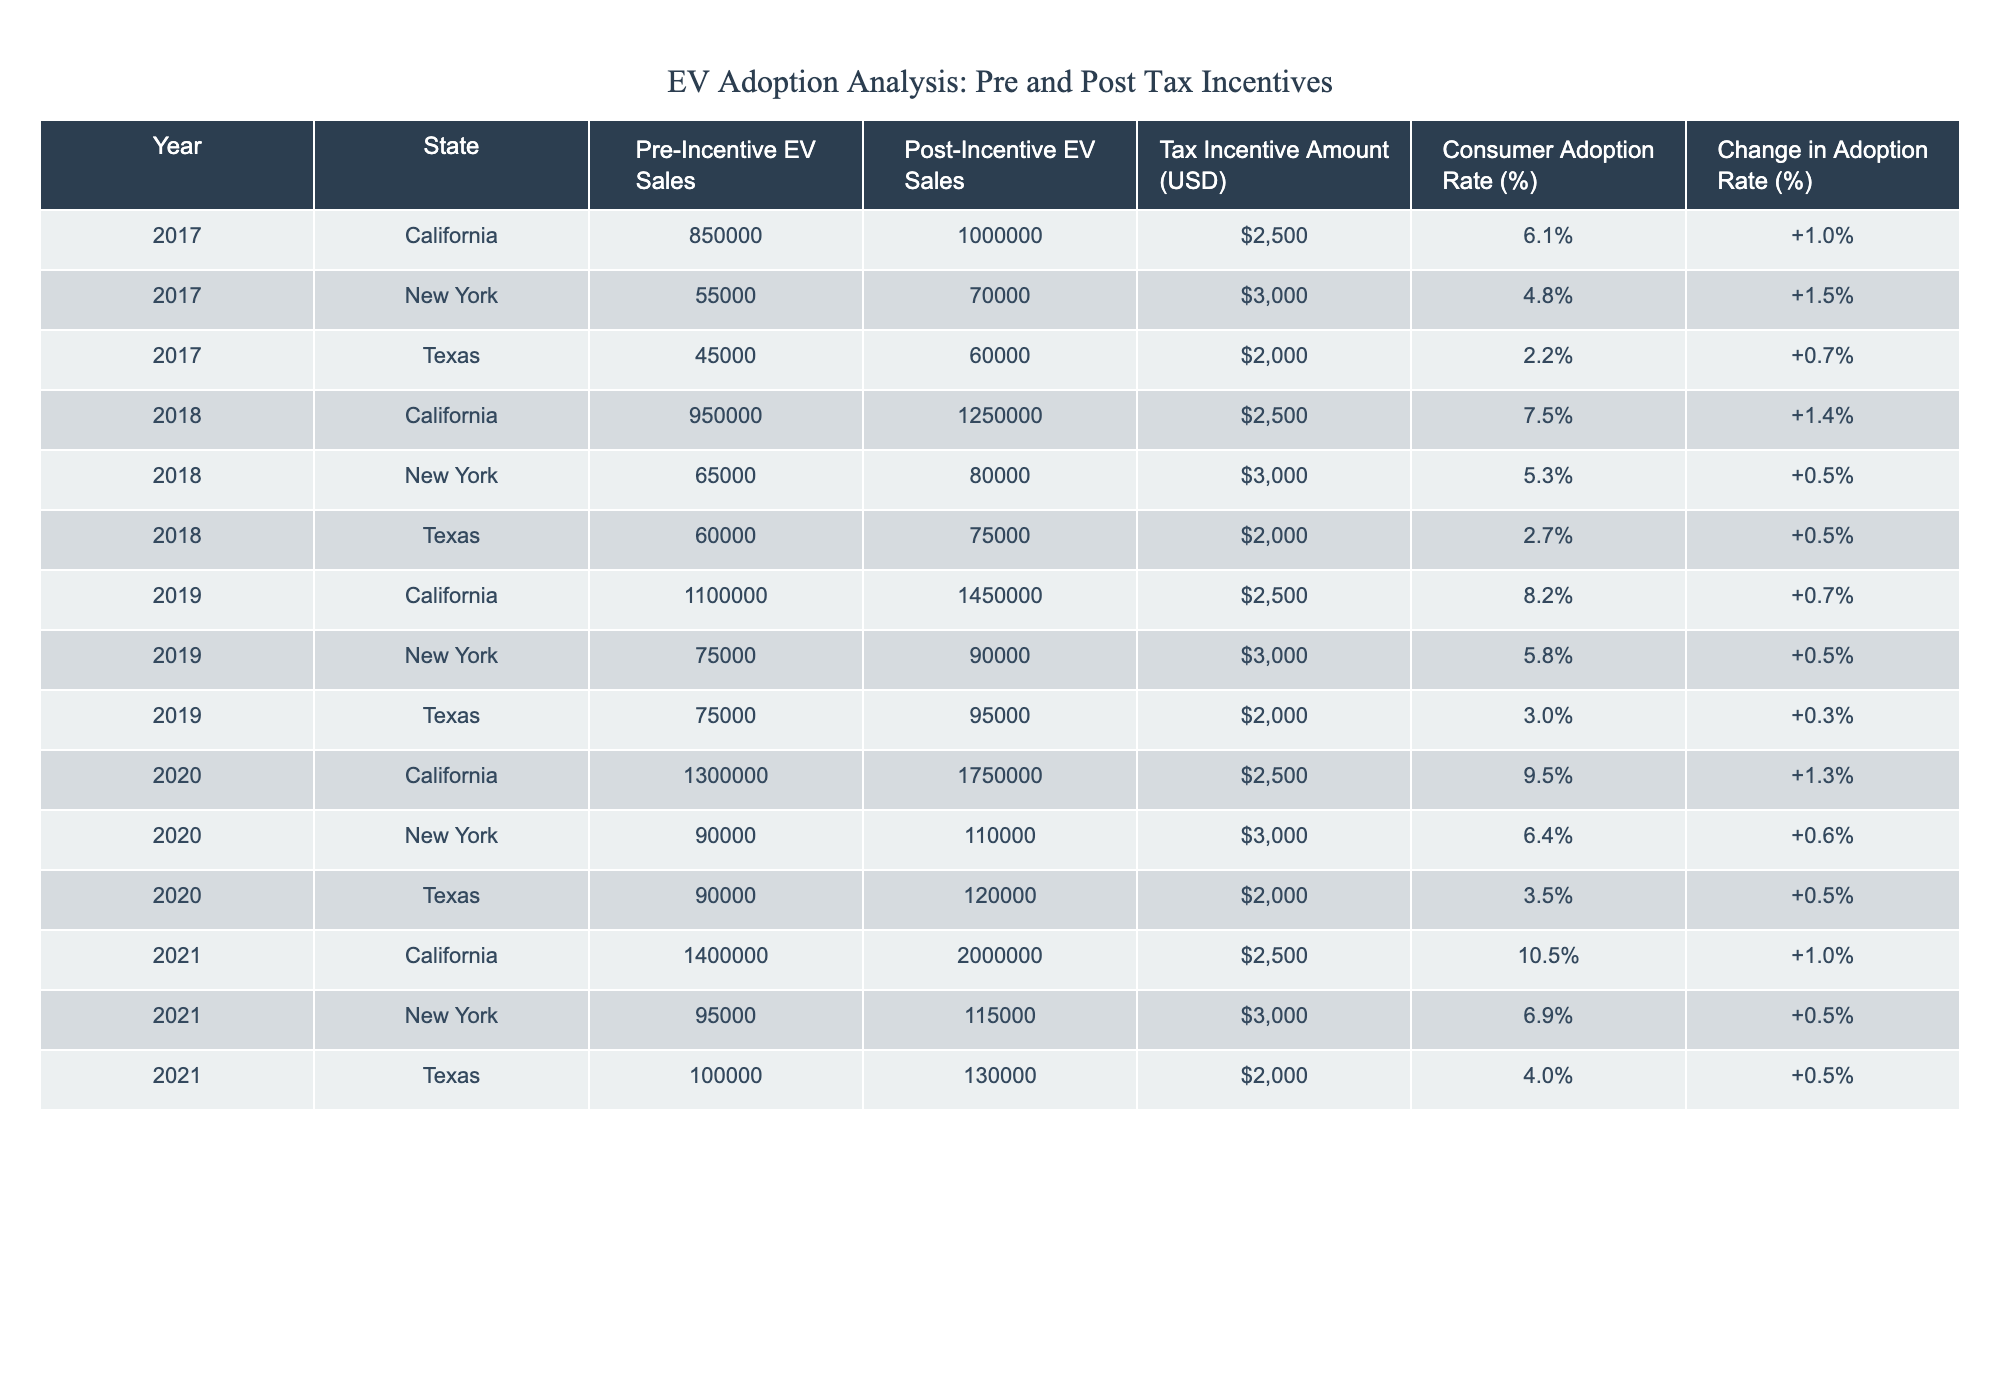What was the Tax Incentive Amount in New York for 2021? Looking at the row corresponding to New York in 2021, the table shows the Tax Incentive Amount is listed as $3,000.
Answer: $3,000 What is the Consumer Adoption Rate in Texas for the year 2019? By checking the Texas row for 2019, the Consumer Adoption Rate is recorded as 3.0%.
Answer: 3.0% What was the Change in Adoption Rate for California from 2017 to 2020? In 2017, the Change in Adoption Rate for California is 1.0% and in 2020 it is reported at 1.3%. The difference can be computed as 1.3 - 1.0 = 0.3%.
Answer: 0.3% Did the Consumer Adoption Rate in Texas increase after the implementation of tax incentives in 2021 compared to the previous year? For Texas, the Consumer Adoption Rate in 2021 is 4.0%, while in 2020 it was 3.5%. The rate increased by 0.5%, hence the answer is yes.
Answer: Yes What is the average Tax Incentive Amount for all states in 2020? For 2020, the rows for California, New York, and Texas report tax incentives of $2,500, $3,000, and $2,000 respectively. To find the average, we sum them up: 2500 + 3000 + 2000 = 7500, then divide by 3 giving us an average of 7500/3 = 2500.
Answer: $2,500 Which state had the highest Post-Incentive EV Sales in 2021? Looking at the Post-Incentive EV Sales for 2021, California had sales of 2,000,000, which is higher than New York's 115,000 and Texas's 130,000. Therefore, California had the highest sales.
Answer: California What was the Change in Adoption Rate in New York from 2018 to 2019? In New York, the Change in Adoption Rate was 0.5% for 2018 and 0.5% for 2019. Hence, the difference is 0.5 - 0.5 = 0%, meaning there was no change in the adoption rate.
Answer: 0% Did Texas see a higher adoption rate percentage in 2020 than the previous year? The Consumer Adoption Rate in Texas for 2020 was 3.5% and for 2019 it was 3.0%. Since 3.5% is greater than 3.0%, this means there was an increase.
Answer: Yes 